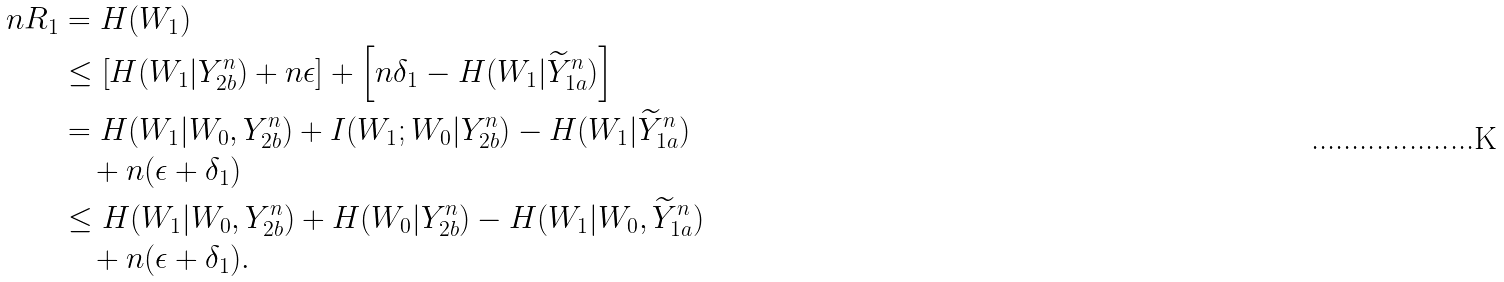Convert formula to latex. <formula><loc_0><loc_0><loc_500><loc_500>n R _ { 1 } & = H ( W _ { 1 } ) \\ & \leq \left [ H ( W _ { 1 } | Y _ { 2 b } ^ { n } ) + n \epsilon \right ] + \left [ n \delta _ { 1 } - H ( W _ { 1 } | \widetilde { Y } _ { 1 a } ^ { n } ) \right ] \\ & = H ( W _ { 1 } | W _ { 0 } , Y _ { 2 b } ^ { n } ) + I ( W _ { 1 } ; W _ { 0 } | Y _ { 2 b } ^ { n } ) - H ( W _ { 1 } | \widetilde { Y } _ { 1 a } ^ { n } ) \\ & \quad + n ( \epsilon + \delta _ { 1 } ) \\ & \leq H ( W _ { 1 } | W _ { 0 } , Y _ { 2 b } ^ { n } ) + H ( W _ { 0 } | Y _ { 2 b } ^ { n } ) - H ( W _ { 1 } | W _ { 0 } , \widetilde { Y } _ { 1 a } ^ { n } ) \\ & \quad + n ( \epsilon + \delta _ { 1 } ) .</formula> 